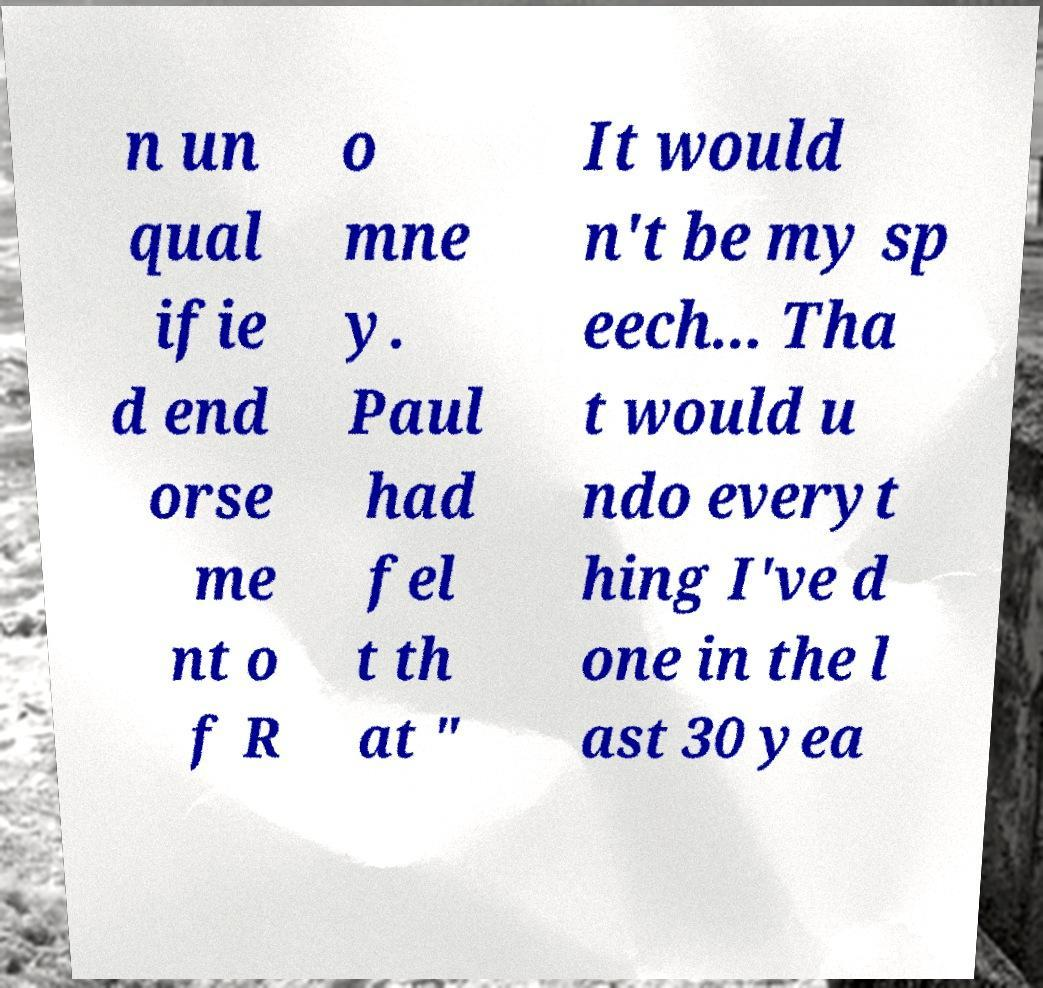Could you assist in decoding the text presented in this image and type it out clearly? n un qual ifie d end orse me nt o f R o mne y. Paul had fel t th at " It would n't be my sp eech... Tha t would u ndo everyt hing I've d one in the l ast 30 yea 